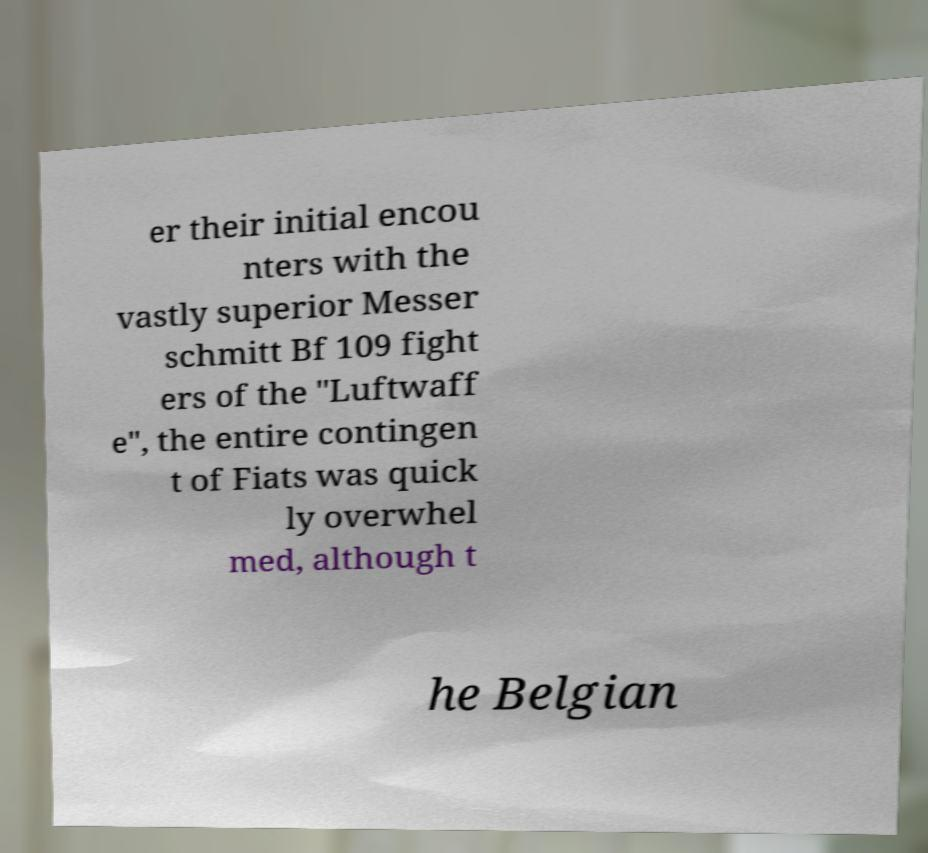Can you read and provide the text displayed in the image?This photo seems to have some interesting text. Can you extract and type it out for me? er their initial encou nters with the vastly superior Messer schmitt Bf 109 fight ers of the "Luftwaff e", the entire contingen t of Fiats was quick ly overwhel med, although t he Belgian 